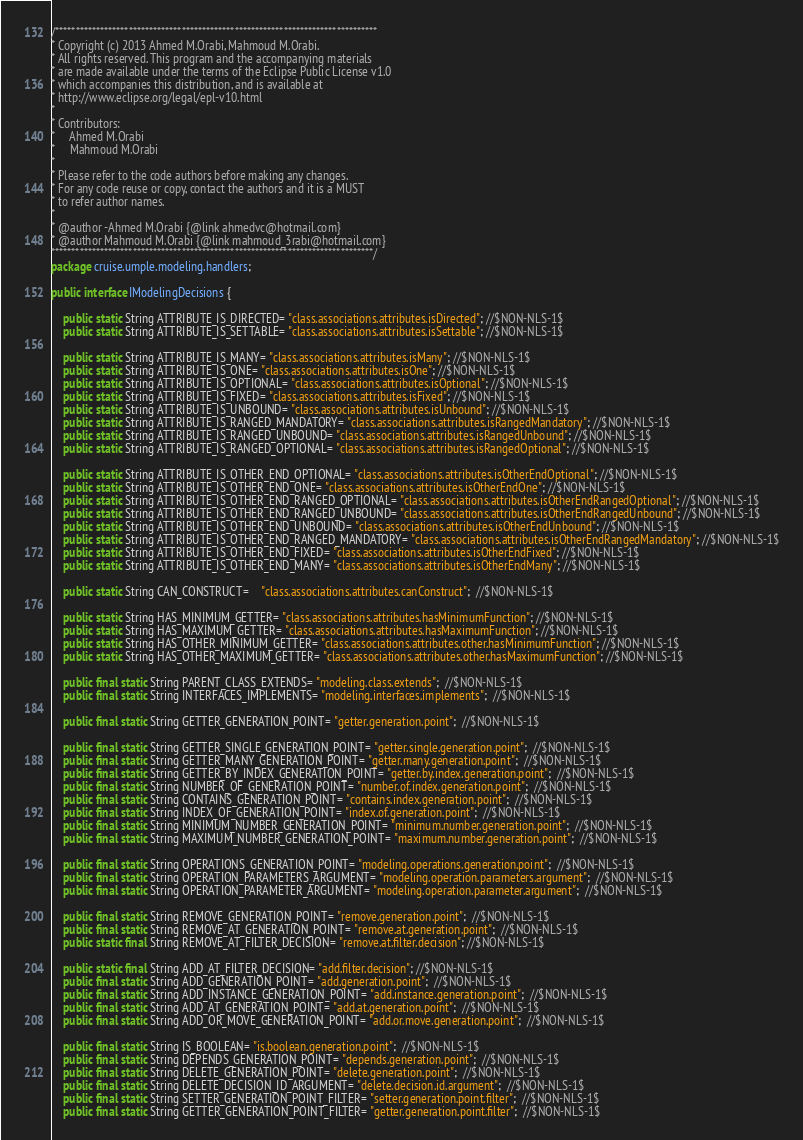<code> <loc_0><loc_0><loc_500><loc_500><_Java_>/*******************************************************************************
* Copyright (c) 2013 Ahmed M.Orabi, Mahmoud M.Orabi.
* All rights reserved. This program and the accompanying materials
* are made available under the terms of the Eclipse Public License v1.0
* which accompanies this distribution, and is available at
* http://www.eclipse.org/legal/epl-v10.html
*
* Contributors:
*     Ahmed M.Orabi
*     Mahmoud M.Orabi
*
* Please refer to the code authors before making any changes. 
* For any code reuse or copy, contact the authors and it is a MUST 
* to refer author names.
*
* @author -Ahmed M.Orabi {@link ahmedvc@hotmail.com}
* @author Mahmoud M.Orabi {@link mahmoud_3rabi@hotmail.com}
*******************************************************************************/
package cruise.umple.modeling.handlers;

public interface IModelingDecisions {

	public static String ATTRIBUTE_IS_DIRECTED= "class.associations.attributes.isDirected"; //$NON-NLS-1$
	public static String ATTRIBUTE_IS_SETTABLE= "class.associations.attributes.isSettable"; //$NON-NLS-1$
	
	public static String ATTRIBUTE_IS_MANY= "class.associations.attributes.isMany"; //$NON-NLS-1$
	public static String ATTRIBUTE_IS_ONE= "class.associations.attributes.isOne"; //$NON-NLS-1$
	public static String ATTRIBUTE_IS_OPTIONAL= "class.associations.attributes.isOptional"; //$NON-NLS-1$
	public static String ATTRIBUTE_IS_FIXED= "class.associations.attributes.isFixed"; //$NON-NLS-1$
	public static String ATTRIBUTE_IS_UNBOUND= "class.associations.attributes.isUnbound"; //$NON-NLS-1$
	public static String ATTRIBUTE_IS_RANGED_MANDATORY= "class.associations.attributes.isRangedMandatory"; //$NON-NLS-1$
	public static String ATTRIBUTE_IS_RANGED_UNBOUND= "class.associations.attributes.isRangedUnbound"; //$NON-NLS-1$
	public static String ATTRIBUTE_IS_RANGED_OPTIONAL= "class.associations.attributes.isRangedOptional"; //$NON-NLS-1$
	
	public static String ATTRIBUTE_IS_OTHER_END_OPTIONAL= "class.associations.attributes.isOtherEndOptional"; //$NON-NLS-1$
	public static String ATTRIBUTE_IS_OTHER_END_ONE= "class.associations.attributes.isOtherEndOne"; //$NON-NLS-1$
	public static String ATTRIBUTE_IS_OTHER_END_RANGED_OPTIONAL= "class.associations.attributes.isOtherEndRangedOptional"; //$NON-NLS-1$
	public static String ATTRIBUTE_IS_OTHER_END_RANGED_UNBOUND= "class.associations.attributes.isOtherEndRangedUnbound"; //$NON-NLS-1$
	public static String ATTRIBUTE_IS_OTHER_END_UNBOUND= "class.associations.attributes.isOtherEndUnbound"; //$NON-NLS-1$
	public static String ATTRIBUTE_IS_OTHER_END_RANGED_MANDATORY= "class.associations.attributes.isOtherEndRangedMandatory"; //$NON-NLS-1$
	public static String ATTRIBUTE_IS_OTHER_END_FIXED= "class.associations.attributes.isOtherEndFixed"; //$NON-NLS-1$
	public static String ATTRIBUTE_IS_OTHER_END_MANY= "class.associations.attributes.isOtherEndMany"; //$NON-NLS-1$
	
	public static String CAN_CONSTRUCT=	"class.associations.attributes.canConstruct";  //$NON-NLS-1$
	
	public static String HAS_MINIMUM_GETTER= "class.associations.attributes.hasMinimumFunction"; //$NON-NLS-1$
	public static String HAS_MAXIMUM_GETTER= "class.associations.attributes.hasMaximumFunction"; //$NON-NLS-1$
	public static String HAS_OTHER_MINIMUM_GETTER= "class.associations.attributes.other.hasMinimumFunction"; //$NON-NLS-1$
	public static String HAS_OTHER_MAXIMUM_GETTER= "class.associations.attributes.other.hasMaximumFunction"; //$NON-NLS-1$
	
	public final static String PARENT_CLASS_EXTENDS= "modeling.class.extends";  //$NON-NLS-1$
	public final static String INTERFACES_IMPLEMENTS= "modeling.interfaces.implements";  //$NON-NLS-1$
	
	public final static String GETTER_GENERATION_POINT= "getter.generation.point";  //$NON-NLS-1$
	
	public final static String GETTER_SINGLE_GENERATION_POINT= "getter.single.generation.point";  //$NON-NLS-1$
	public final static String GETTER_MANY_GENERATION_POINT= "getter.many.generation.point";  //$NON-NLS-1$
	public final static String GETTER_BY_INDEX_GENERATION_POINT= "getter.by.index.generation.point";  //$NON-NLS-1$
	public final static String NUMBER_OF_GENERATION_POINT= "number.of.index.generation.point";  //$NON-NLS-1$
	public final static String CONTAINS_GENERATION_POINT= "contains.index.generation.point";  //$NON-NLS-1$
	public final static String INDEX_OF_GENERATION_POINT= "index.of.generation.point";  //$NON-NLS-1$
	public final static String MINIMUM_NUMBER_GENERATION_POINT= "minimum.number.generation.point";  //$NON-NLS-1$
	public final static String MAXIMUM_NUMBER_GENERATION_POINT= "maximum.number.generation.point";  //$NON-NLS-1$
	
	public final static String OPERATIONS_GENERATION_POINT= "modeling.operations.generation.point";  //$NON-NLS-1$
	public final static String OPERATION_PARAMETERS_ARGUMENT= "modeling.operation.parameters.argument";  //$NON-NLS-1$
	public final static String OPERATION_PARAMETER_ARGUMENT= "modeling.operation.parameter.argument";  //$NON-NLS-1$
	
	public final static String REMOVE_GENERATION_POINT= "remove.generation.point";  //$NON-NLS-1$
	public final static String REMOVE_AT_GENERATION_POINT= "remove.at.generation.point";  //$NON-NLS-1$
	public static final String REMOVE_AT_FILTER_DECISION= "remove.at.filter.decision"; //$NON-NLS-1$
	
	public static final String ADD_AT_FILTER_DECISION= "add.filter.decision"; //$NON-NLS-1$
	public final static String ADD_GENERATION_POINT= "add.generation.point";  //$NON-NLS-1$
	public final static String ADD_INSTANCE_GENERATION_POINT= "add.instance.generation.point";  //$NON-NLS-1$
	public final static String ADD_AT_GENERATION_POINT= "add.at.generation.point";  //$NON-NLS-1$
	public final static String ADD_OR_MOVE_GENERATION_POINT= "add.or.move.generation.point";  //$NON-NLS-1$
	
	public final static String IS_BOOLEAN= "is.boolean.generation.point";  //$NON-NLS-1$
	public final static String DEPENDS_GENERATION_POINT= "depends.generation.point";  //$NON-NLS-1$
	public final static String DELETE_GENERATION_POINT= "delete.generation.point";  //$NON-NLS-1$
	public final static String DELETE_DECISION_ID_ARGUMENT= "delete.decision.id.argument";  //$NON-NLS-1$
	public final static String SETTER_GENERATION_POINT_FILTER= "setter.generation.point.filter";  //$NON-NLS-1$
	public final static String GETTER_GENERATION_POINT_FILTER= "getter.generation.point.filter";  //$NON-NLS-1$</code> 